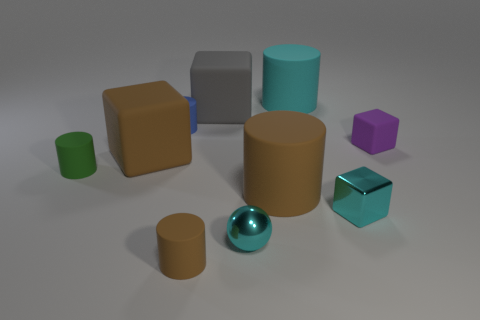What is the material of the tiny thing that is both to the right of the large gray rubber object and to the left of the large cyan cylinder? The tiny object located between the large gray rubber cube and the large cyan cylinder appears to be a small, spherical item with a metallic sheen, suggesting it is made of metal. 